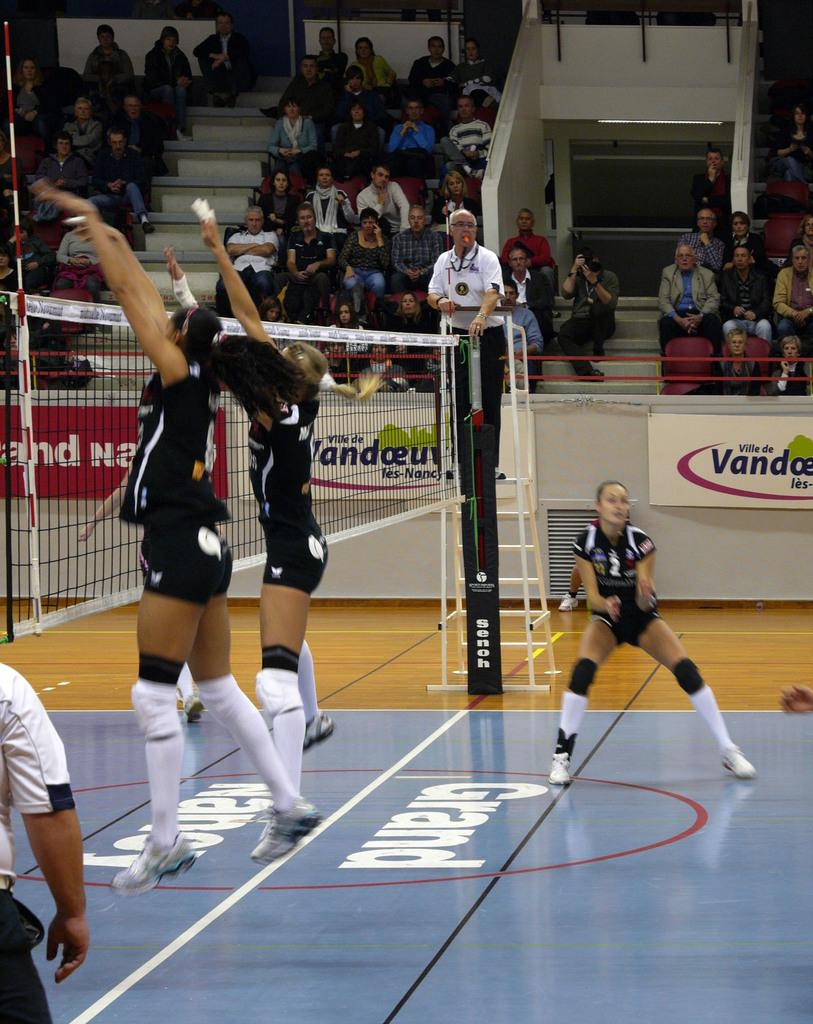<image>
Share a concise interpretation of the image provided. Girls play volleyball on mats labeled with the word Grand. 